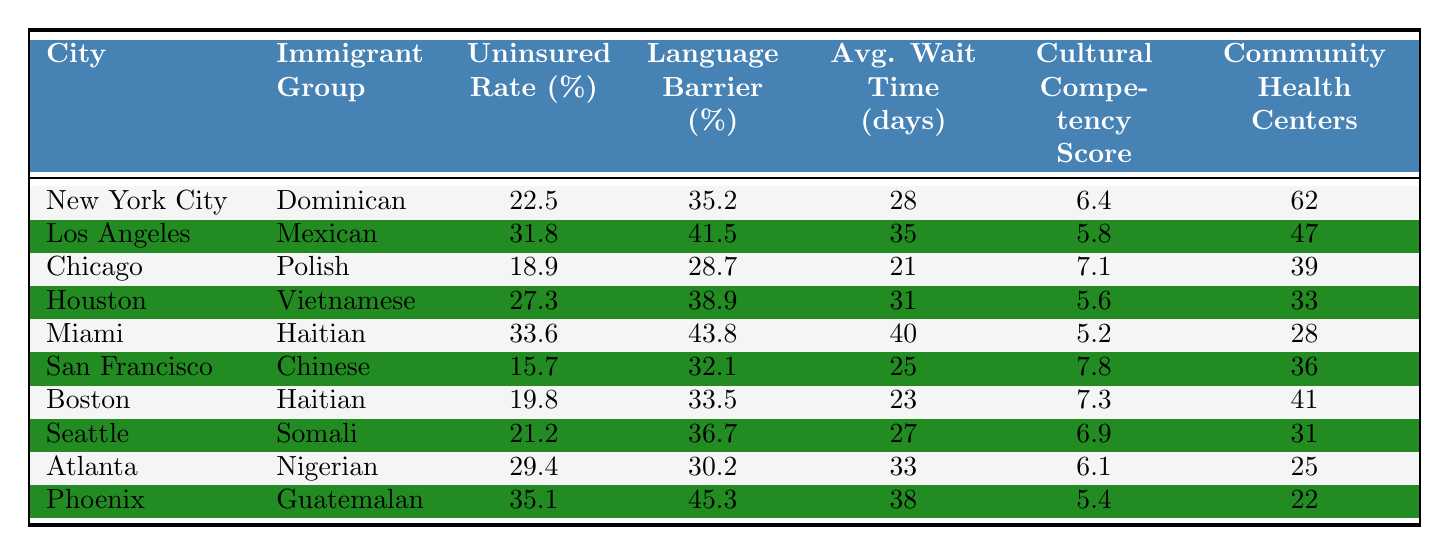What is the uninsured rate for immigrants from Miami? The table shows that the uninsured rate for the Haitian immigrant group in Miami is 33.6%.
Answer: 33.6% Which city has the highest average wait time for healthcare services? The table lists Miami with an average wait time of 40 days, which is higher than any other city.
Answer: Miami What is the language barrier percentage for the Nigerian immigrant group in Atlanta? According to the table, the language barrier percentage for the Nigerian immigrant group in Atlanta is 30.2%.
Answer: 30.2% Which immigrant group has the lowest cultural competency score and what is the score? The table indicates that the Haitian immigrant group in Miami has the lowest cultural competency score of 5.2.
Answer: 5.2 What is the difference in the uninsured rates between the Mexican group in Los Angeles and the Polish group in Chicago? The uninsured rate for the Mexican group in Los Angeles is 31.8%, and for the Polish group in Chicago, it is 18.9%. The difference is 31.8% - 18.9% = 12.9%.
Answer: 12.9% What city has the highest number of community health centers, and how many are there? The table shows that New York City has the highest number of community health centers at 62.
Answer: New York City, 62 Which immigrant group has a higher uninsured rate: Vietnamese in Houston or Somali in Seattle? The uninsured rate for Vietnamese in Houston is 27.3% and for Somali in Seattle is 21.2%. Since 27.3% is greater than 21.2%, the Vietnamese group has a higher uninsured rate.
Answer: Vietnamese in Houston What is the average uninsured rate across all immigrant groups represented in the table? To find the average, sum all uninsured rates: (22.5 + 31.8 + 18.9 + 27.3 + 33.6 + 15.7 + 19.8 + 21.2 + 29.4 + 35.1) =  309.3%. Then divide by the number of groups (10): 309.3% / 10 = 30.93%.
Answer: 30.93% Is it true that all immigrant groups in the listed cities have language barrier percentages above 25%? Checking the table, all language barrier percentages are above 25%, confirming that the statement is true.
Answer: Yes Which city has the immigrant group with the highest language barrier percentage, and what is that percentage? The table shows that the Guatemalan group in Phoenix has the highest language barrier percentage at 45.3%.
Answer: Phoenix, 45.3% 